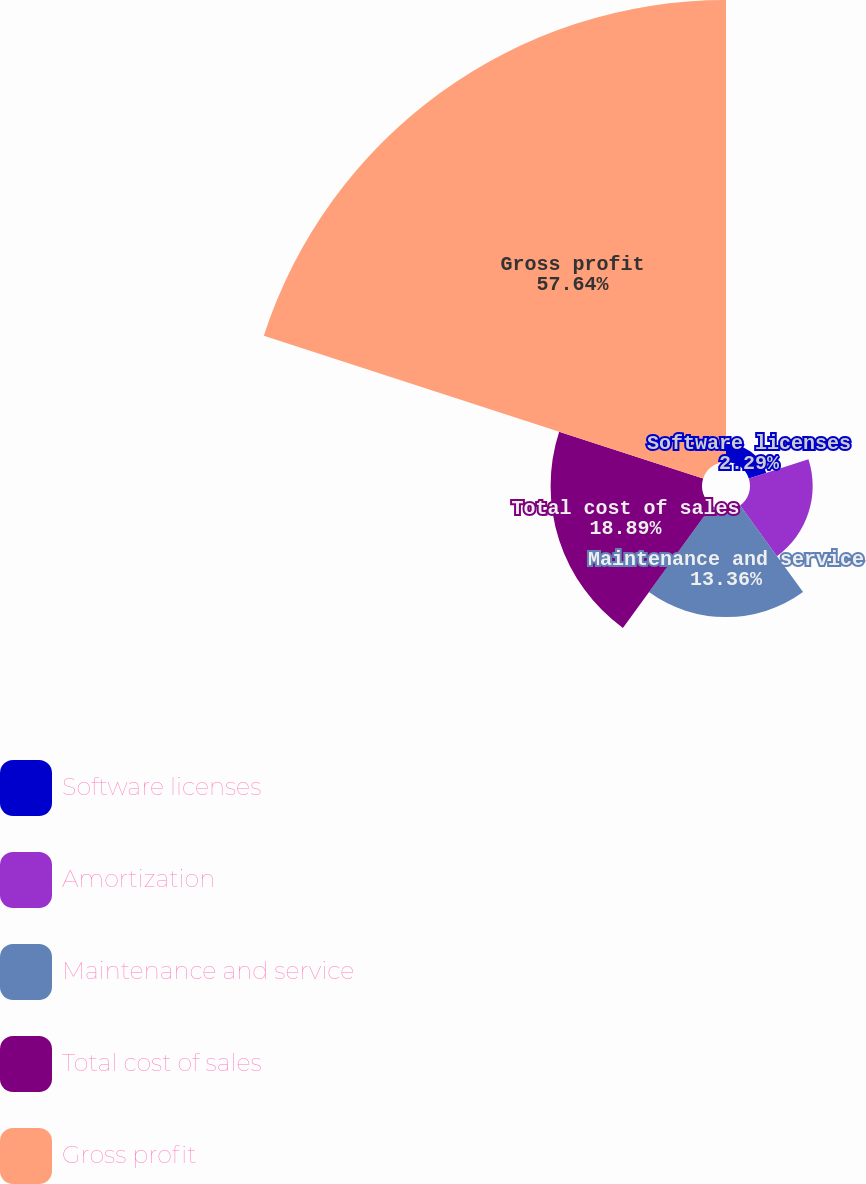Convert chart. <chart><loc_0><loc_0><loc_500><loc_500><pie_chart><fcel>Software licenses<fcel>Amortization<fcel>Maintenance and service<fcel>Total cost of sales<fcel>Gross profit<nl><fcel>2.29%<fcel>7.82%<fcel>13.36%<fcel>18.89%<fcel>57.64%<nl></chart> 